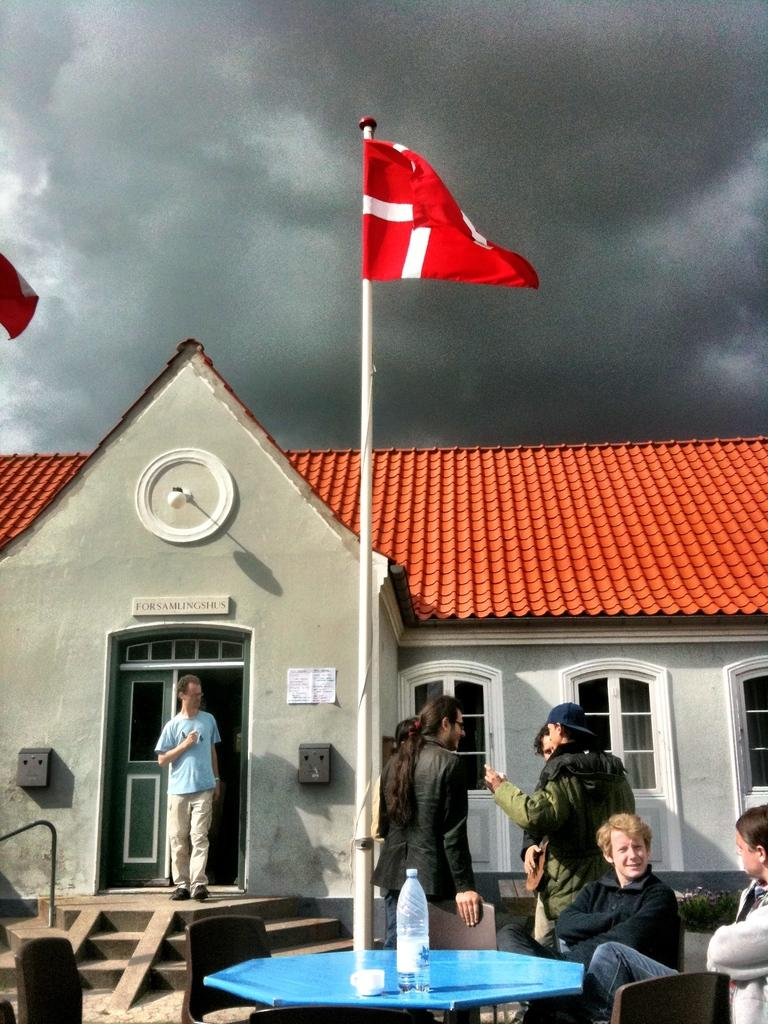What type of structure is visible in the image? There is a building in the image. What are the people in the image doing? There are persons standing on the floor and sitting on chairs in the image. What can be seen on the flag in the image? Unfortunately, the details of the flag are not visible in the image. What items can be seen for hydration in the image? There is a water bottle and a beverage cup in the image. What is visible in the sky in the image? The sky is visible in the image, and there are clouds present. What type of cracker is being used as a hobby in the image? There is no cracker or hobby-related activity present in the image. 